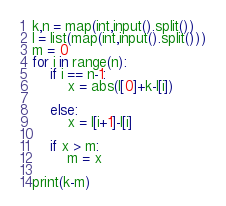Convert code to text. <code><loc_0><loc_0><loc_500><loc_500><_Python_>k,n = map(int,input().split())
l = list(map(int,input().split()))
m = 0
for i in range(n):
    if i == n-1:
        x = abs(l[0]+k-l[i])

    else:
        x = l[i+1]-l[i]

    if x > m:
        m = x

print(k-m)</code> 